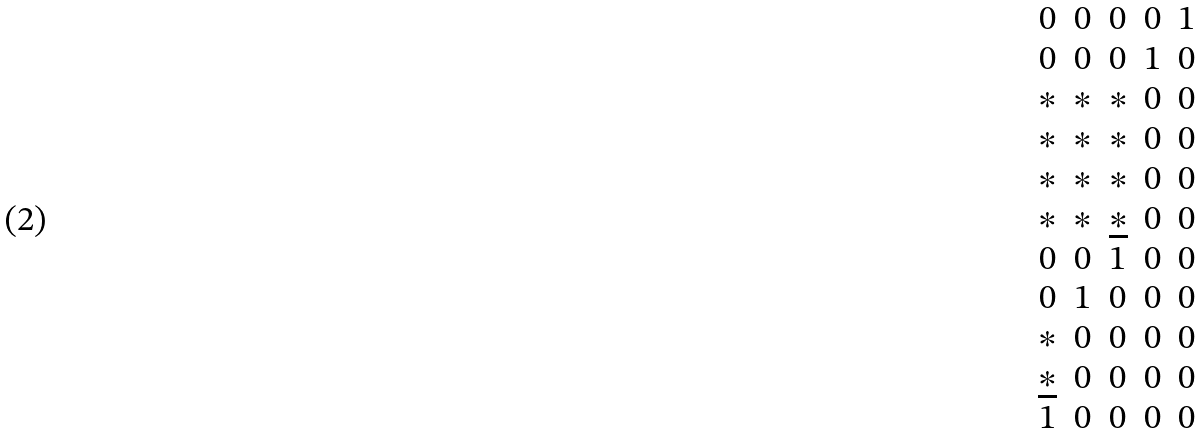<formula> <loc_0><loc_0><loc_500><loc_500>\begin{matrix} 0 & 0 & 0 & 0 & 1 \\ 0 & 0 & 0 & 1 & 0 \\ * & * & * & 0 & 0 \\ * & * & * & 0 & 0 \\ * & * & * & 0 & 0 \\ * & * & \underline { * } & 0 & 0 \\ 0 & 0 & 1 & 0 & 0 \\ 0 & 1 & 0 & 0 & 0 \\ * & 0 & 0 & 0 & 0 \\ \underline { * } & 0 & 0 & 0 & 0 \\ 1 & 0 & 0 & 0 & 0 \\ \end{matrix}</formula> 